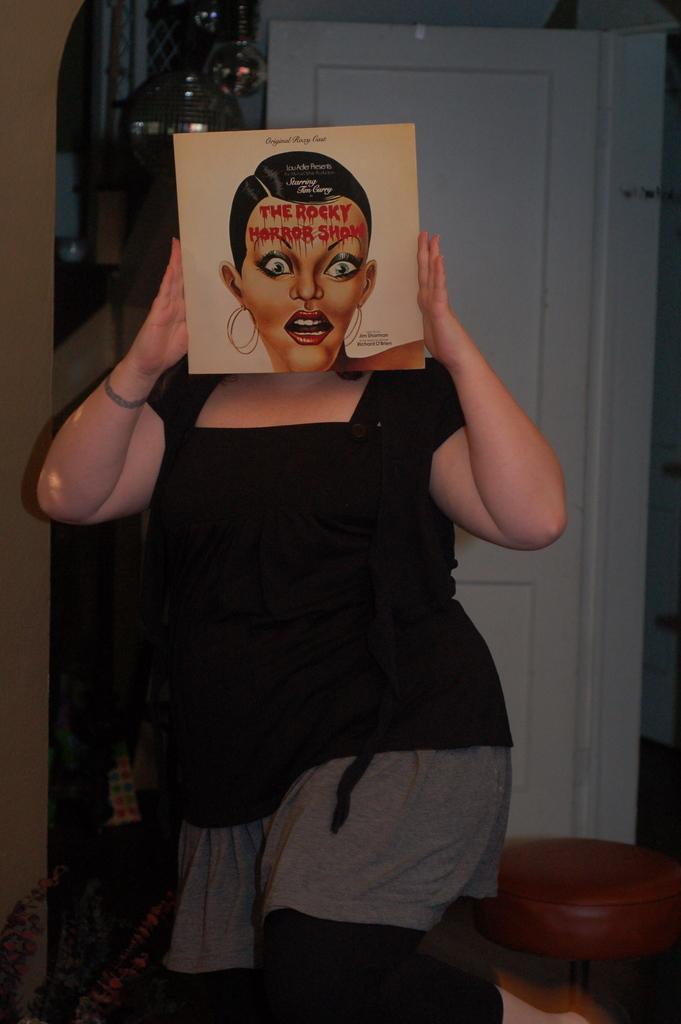Please provide a concise description of this image. In this image there is a woman standing towards the bottom of the image, she is holding a board, there is a woman's face on the board, there is text on the board, there is a stool towards the right of the image, there is a door towards the right of the image, there is a wall towards the left of the image, there is a wall towards the top of the image, there are objects towards the top of the image. 